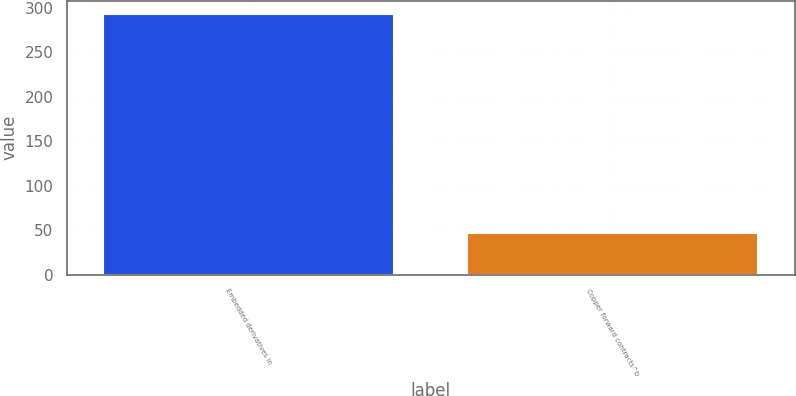Convert chart. <chart><loc_0><loc_0><loc_500><loc_500><bar_chart><fcel>Embedded derivatives in<fcel>Copper forward contracts^b<nl><fcel>293<fcel>47<nl></chart> 